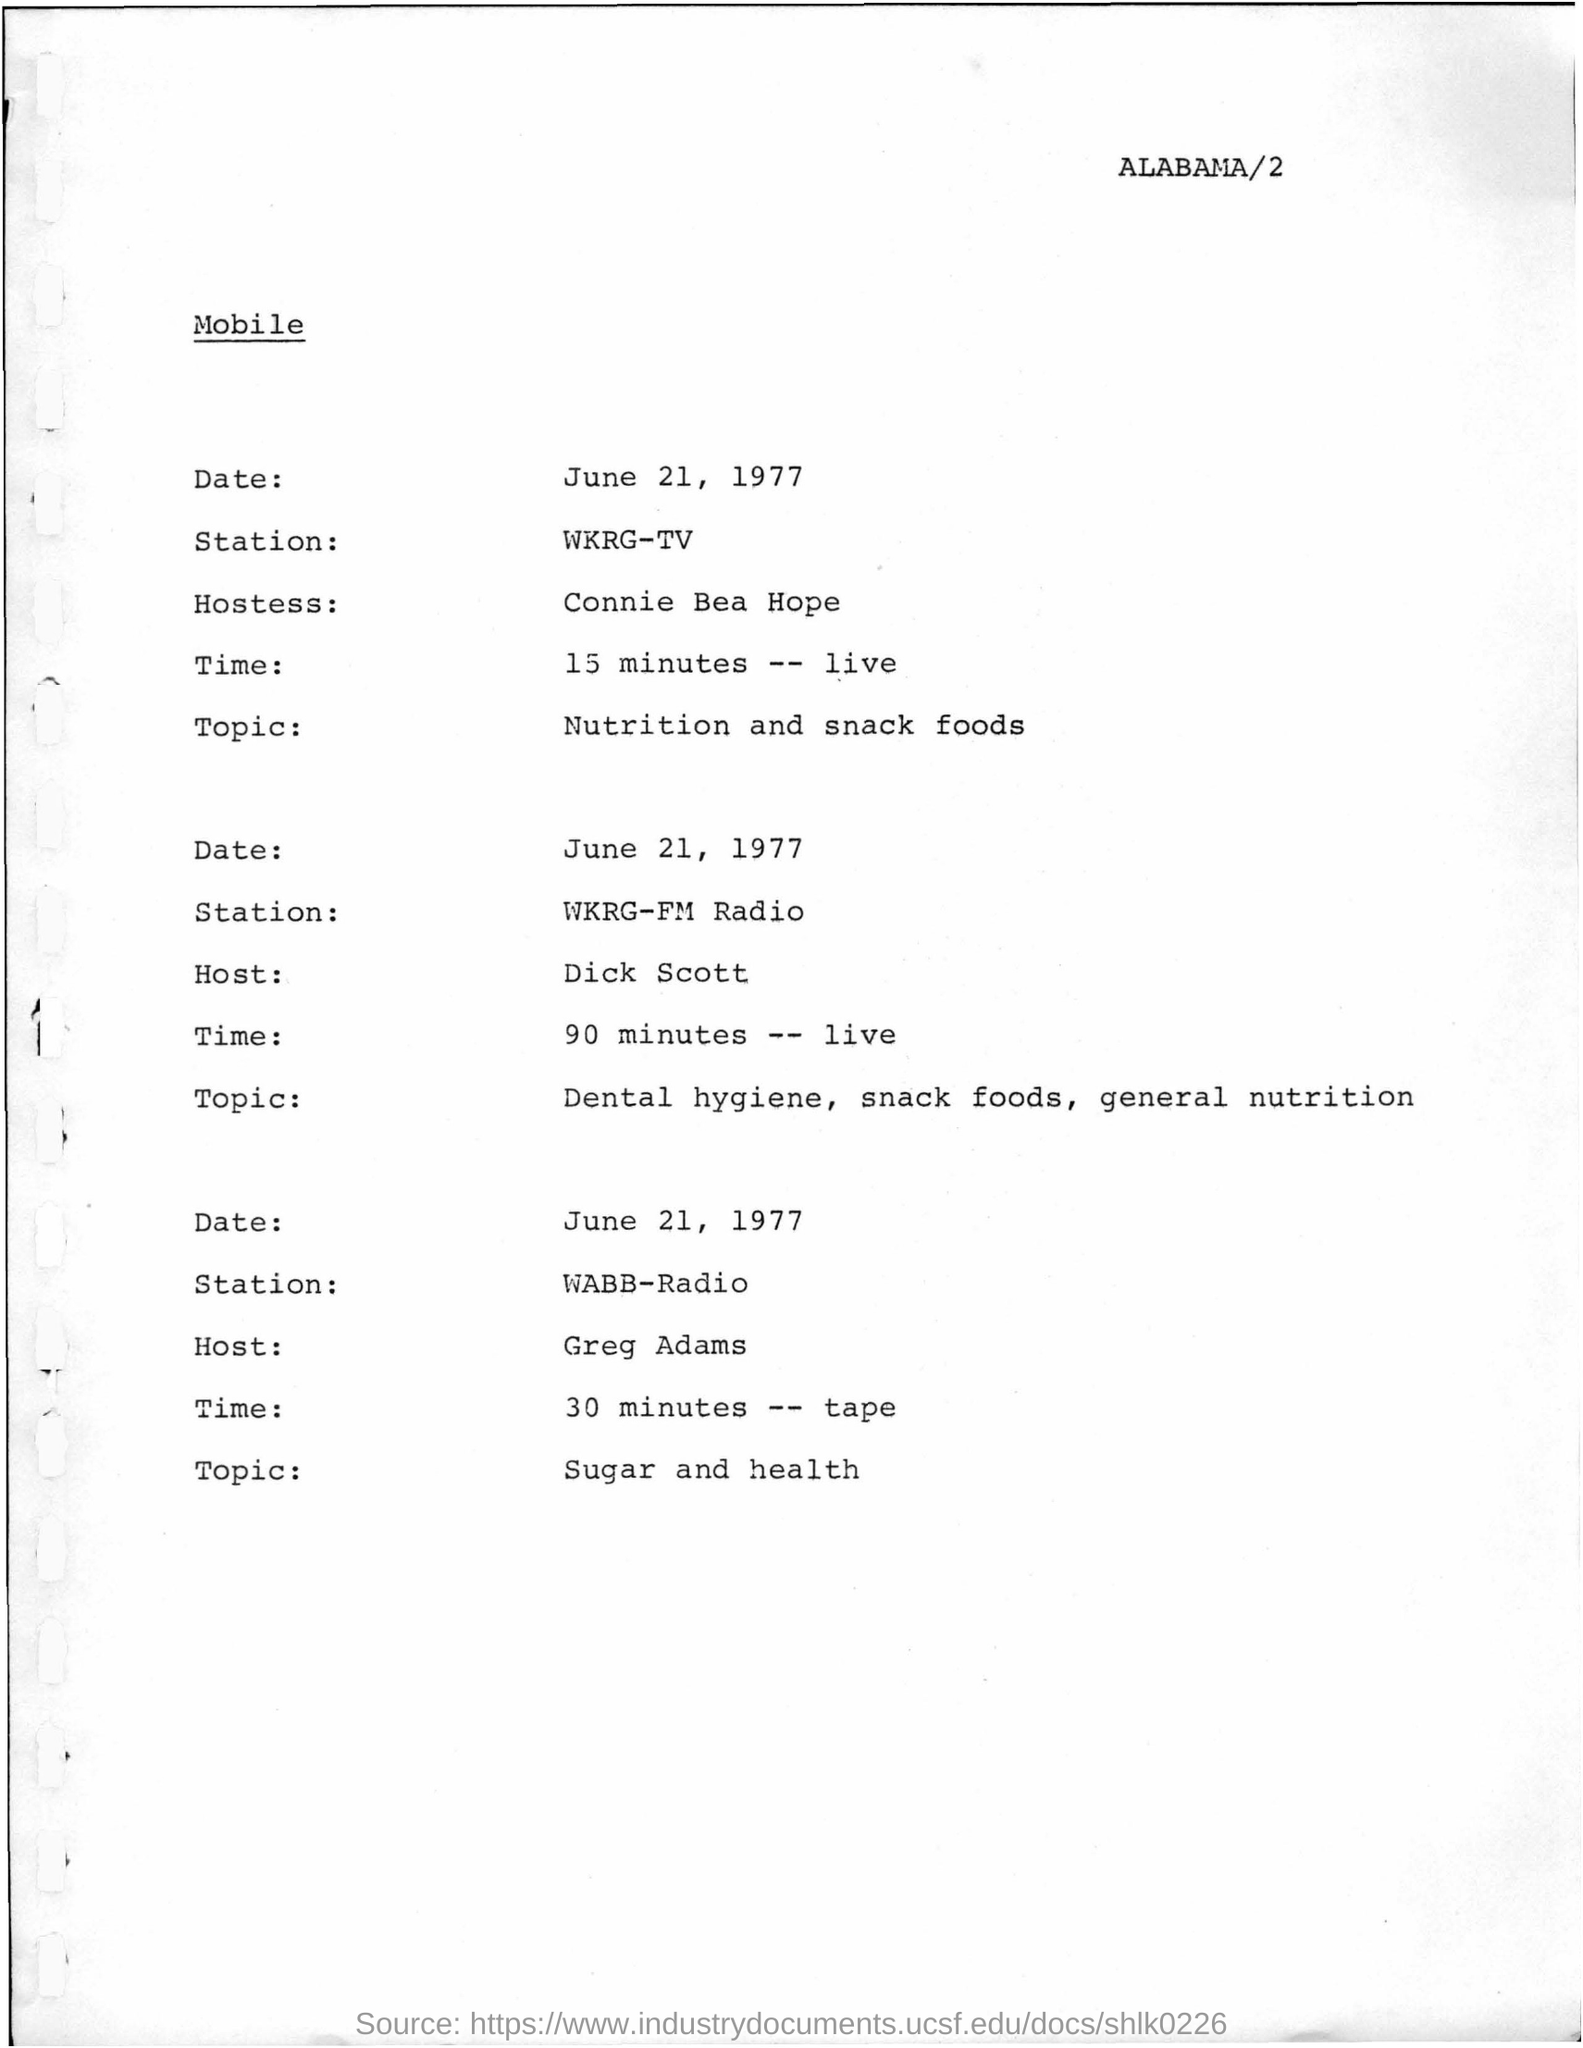Point out several critical features in this image. Greg Adams is the host for the topic of Sugar and Health. The topic of Dental hygiene, snack foods, and general nutrition is scheduled for 90 minutes. The hostess for Nutrition and snack foods is Connie Bea Hope. The radio station mentioned for the topic of sugar and health is WABB-Radio. 